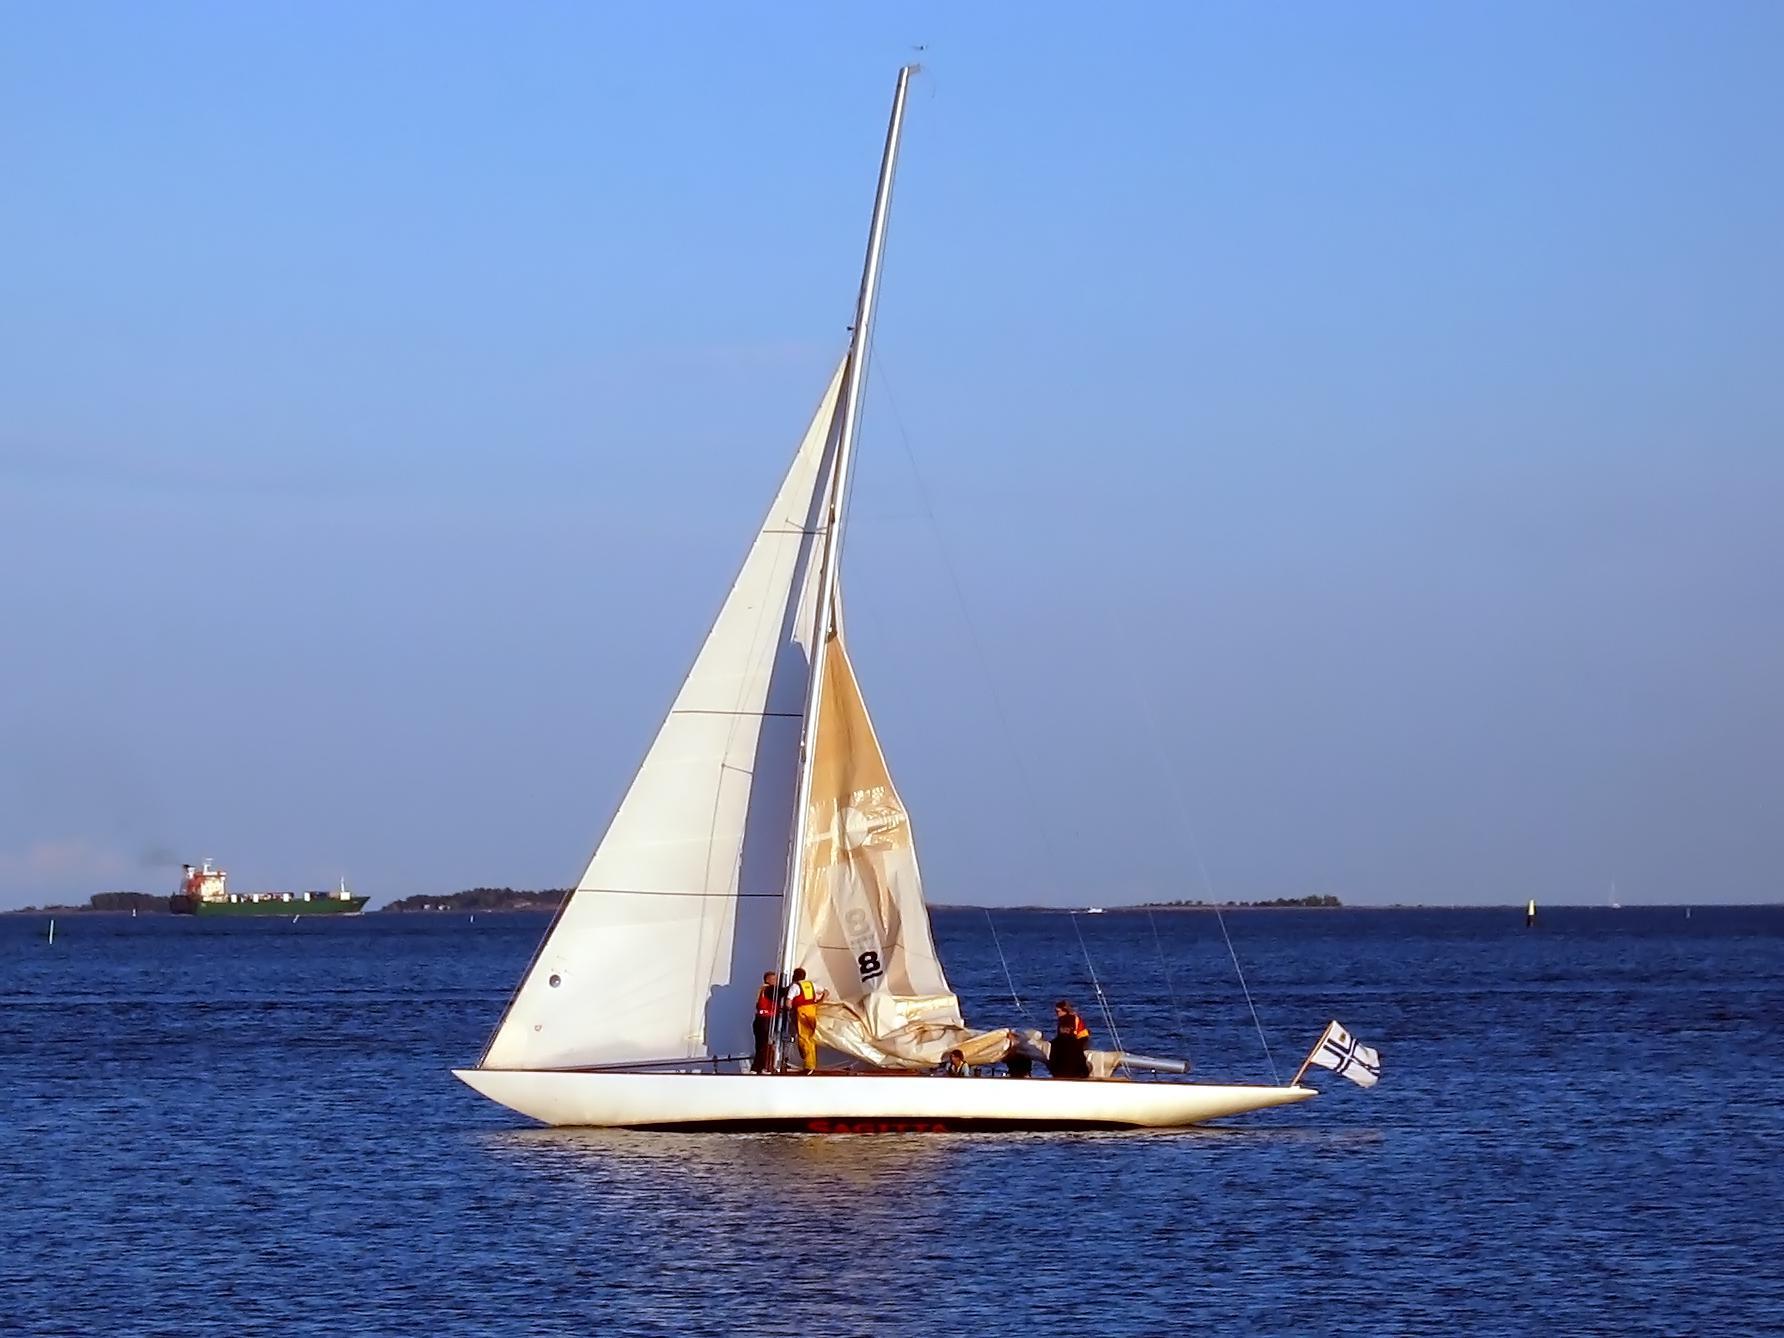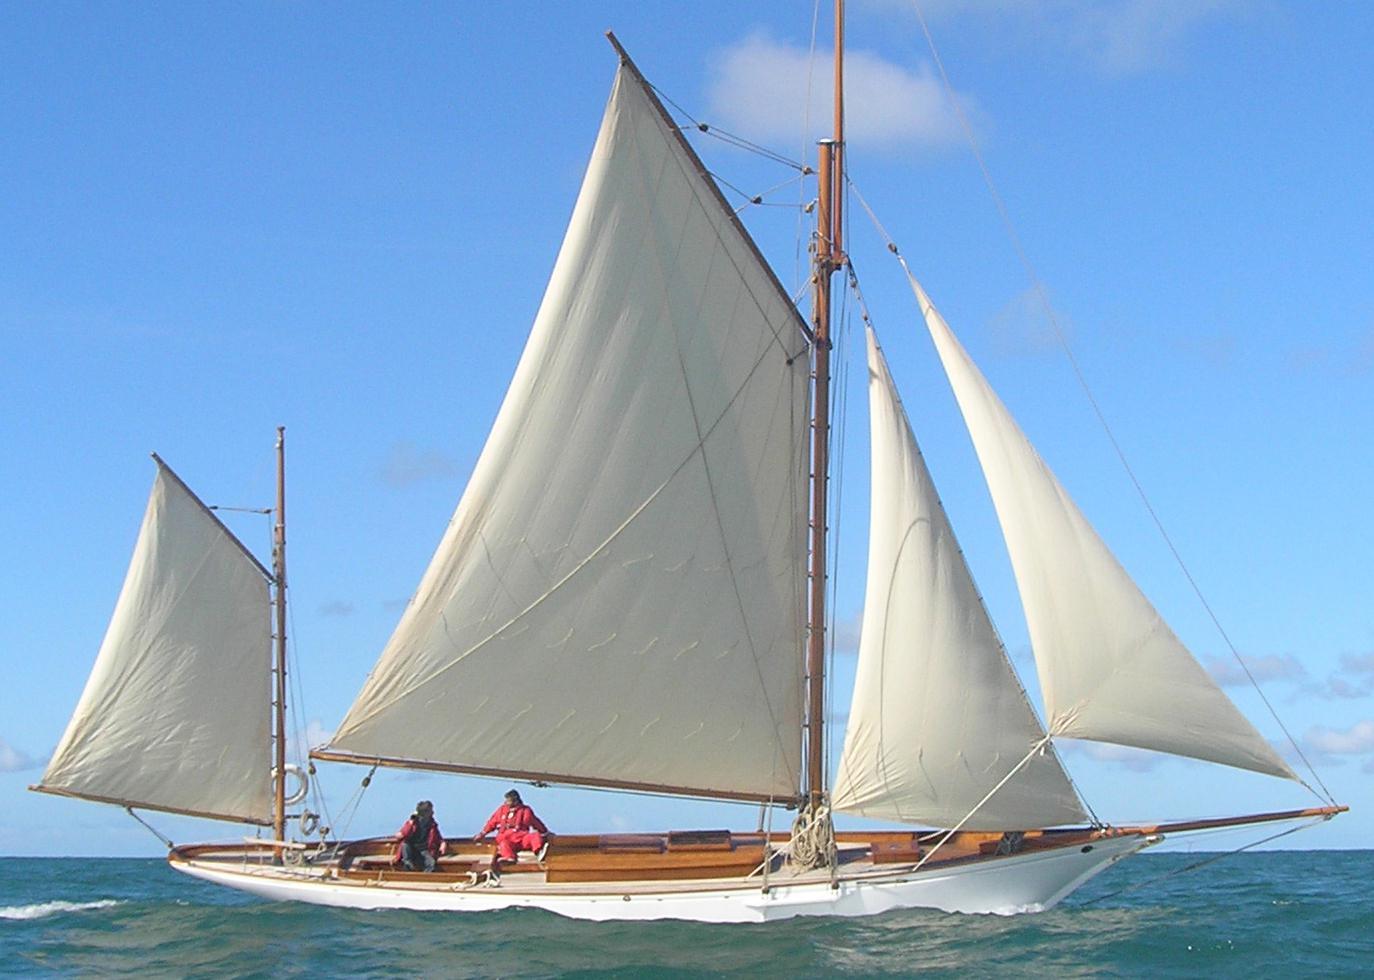The first image is the image on the left, the second image is the image on the right. Considering the images on both sides, is "A sailboat has only 1 large sail and 1 small sail unfurled." valid? Answer yes or no. Yes. The first image is the image on the left, the second image is the image on the right. Analyze the images presented: Is the assertion "A boat has exactly two sails." valid? Answer yes or no. Yes. 